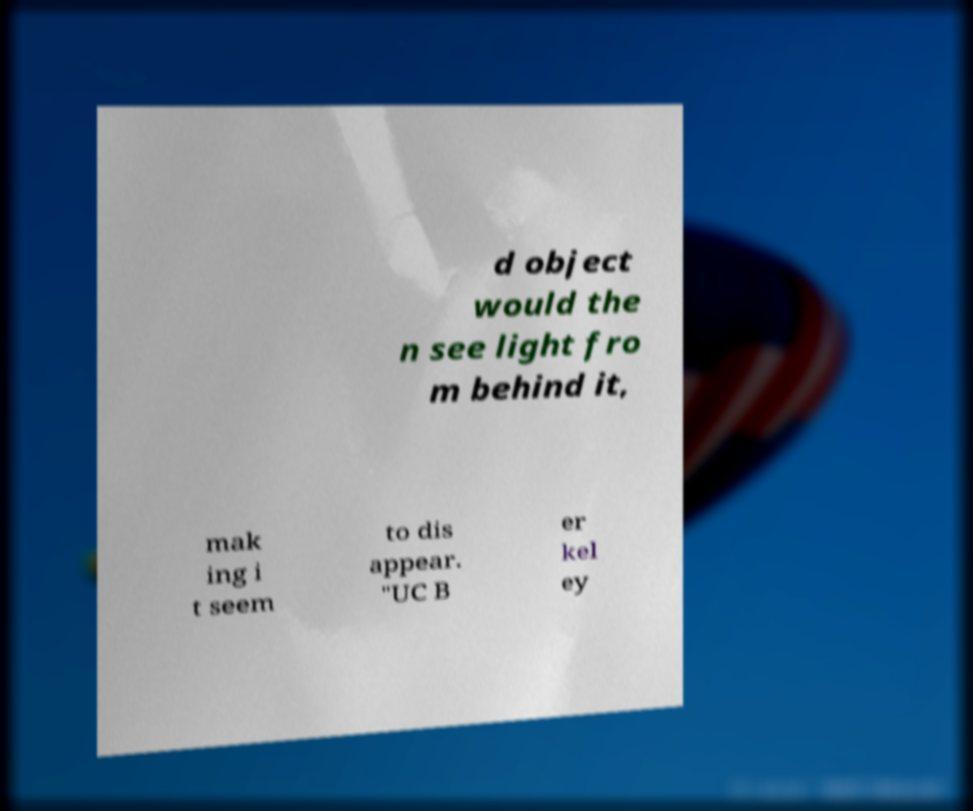Please identify and transcribe the text found in this image. d object would the n see light fro m behind it, mak ing i t seem to dis appear. "UC B er kel ey 